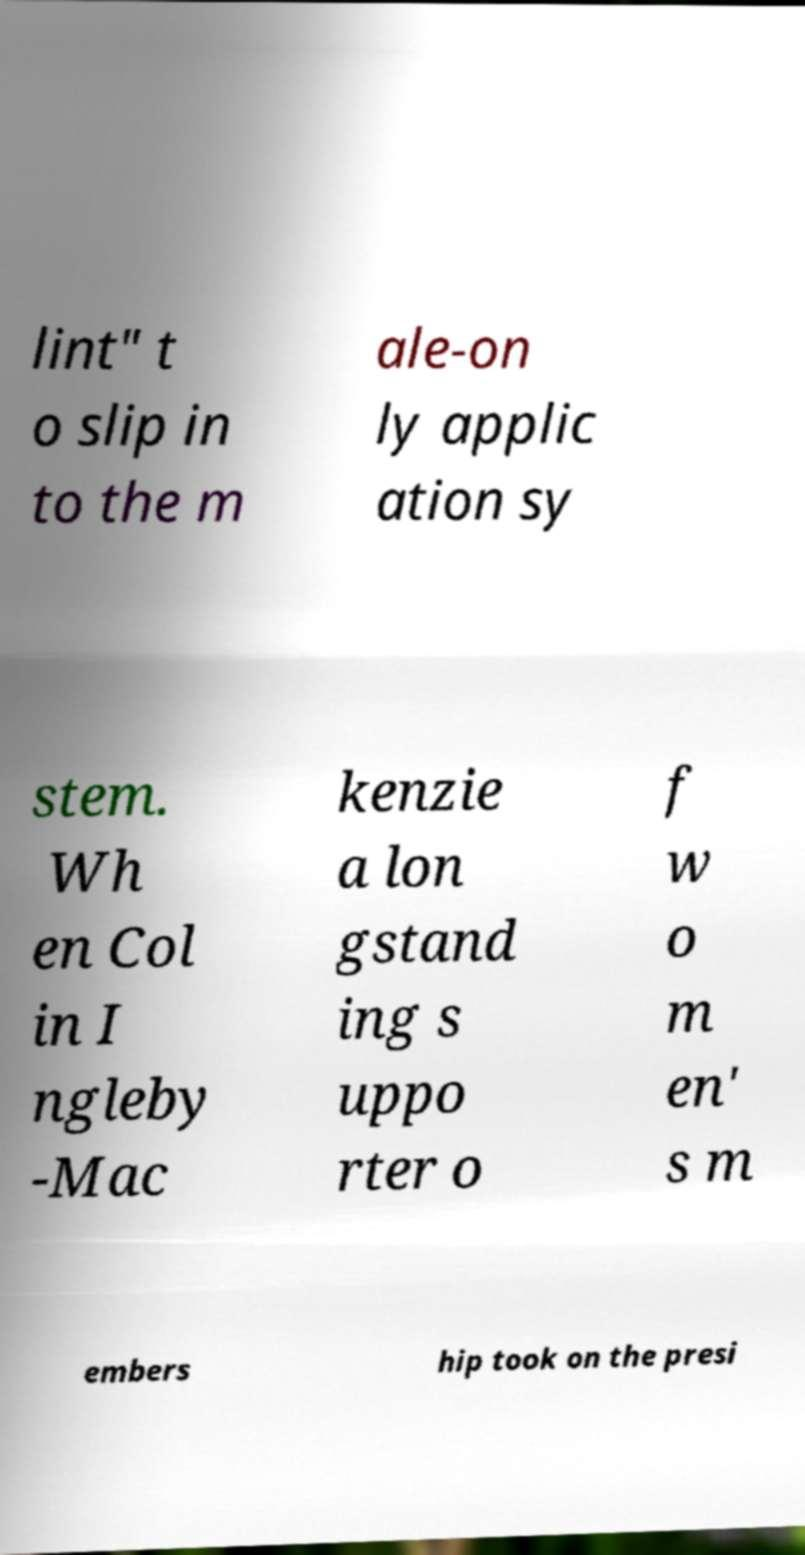Please identify and transcribe the text found in this image. lint" t o slip in to the m ale-on ly applic ation sy stem. Wh en Col in I ngleby -Mac kenzie a lon gstand ing s uppo rter o f w o m en' s m embers hip took on the presi 